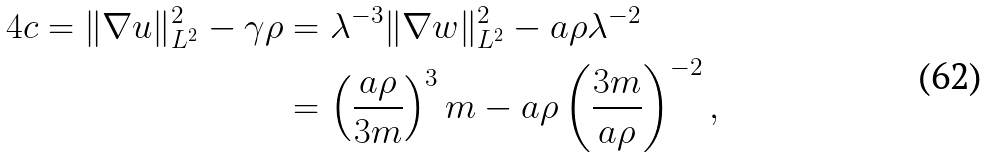Convert formula to latex. <formula><loc_0><loc_0><loc_500><loc_500>4 c = \| \nabla u \| ^ { 2 } _ { L ^ { 2 } } - \gamma \rho & = \lambda ^ { - 3 } \| \nabla w \| ^ { 2 } _ { L ^ { 2 } } - a \rho \lambda ^ { - 2 } \\ & = \left ( \frac { a \rho } { 3 m } \right ) ^ { 3 } m - a \rho \left ( \frac { 3 m } { a \rho } \right ) ^ { - 2 } ,</formula> 